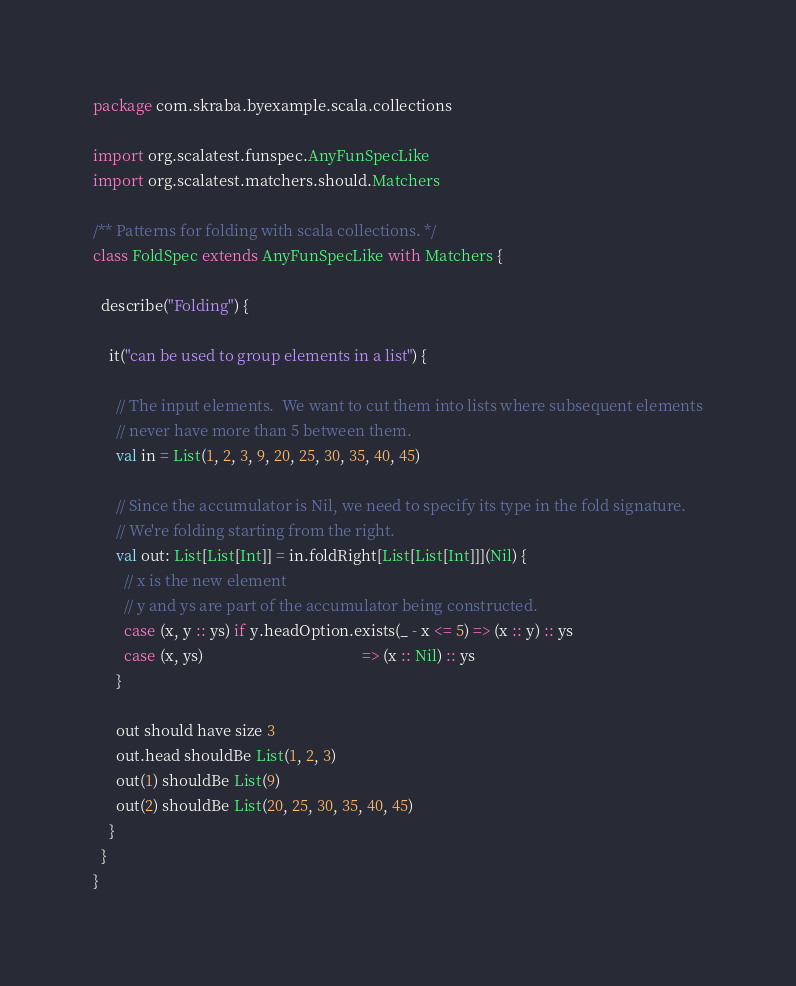<code> <loc_0><loc_0><loc_500><loc_500><_Scala_>package com.skraba.byexample.scala.collections

import org.scalatest.funspec.AnyFunSpecLike
import org.scalatest.matchers.should.Matchers

/** Patterns for folding with scala collections. */
class FoldSpec extends AnyFunSpecLike with Matchers {

  describe("Folding") {

    it("can be used to group elements in a list") {

      // The input elements.  We want to cut them into lists where subsequent elements
      // never have more than 5 between them.
      val in = List(1, 2, 3, 9, 20, 25, 30, 35, 40, 45)

      // Since the accumulator is Nil, we need to specify its type in the fold signature.
      // We're folding starting from the right.
      val out: List[List[Int]] = in.foldRight[List[List[Int]]](Nil) {
        // x is the new element
        // y and ys are part of the accumulator being constructed.
        case (x, y :: ys) if y.headOption.exists(_ - x <= 5) => (x :: y) :: ys
        case (x, ys)                                         => (x :: Nil) :: ys
      }

      out should have size 3
      out.head shouldBe List(1, 2, 3)
      out(1) shouldBe List(9)
      out(2) shouldBe List(20, 25, 30, 35, 40, 45)
    }
  }
}
</code> 